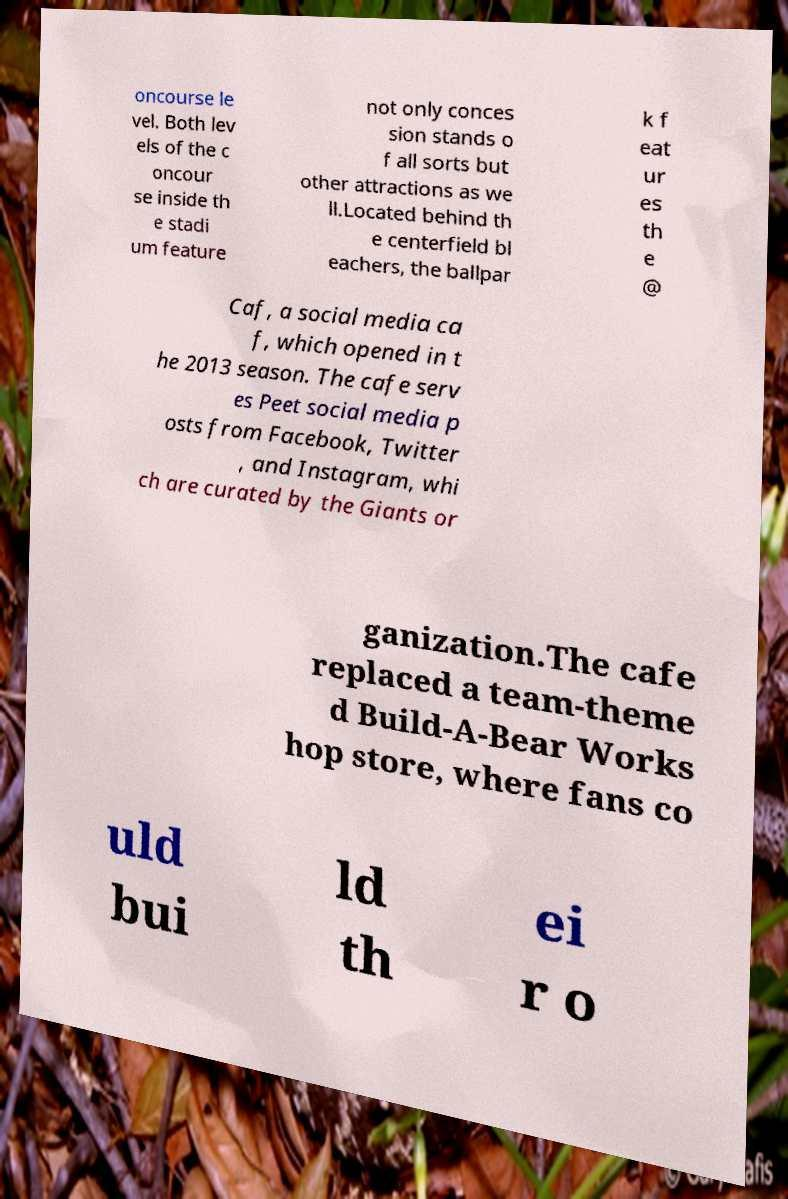Could you extract and type out the text from this image? oncourse le vel. Both lev els of the c oncour se inside th e stadi um feature not only conces sion stands o f all sorts but other attractions as we ll.Located behind th e centerfield bl eachers, the ballpar k f eat ur es th e @ Caf, a social media ca f, which opened in t he 2013 season. The cafe serv es Peet social media p osts from Facebook, Twitter , and Instagram, whi ch are curated by the Giants or ganization.The cafe replaced a team-theme d Build-A-Bear Works hop store, where fans co uld bui ld th ei r o 